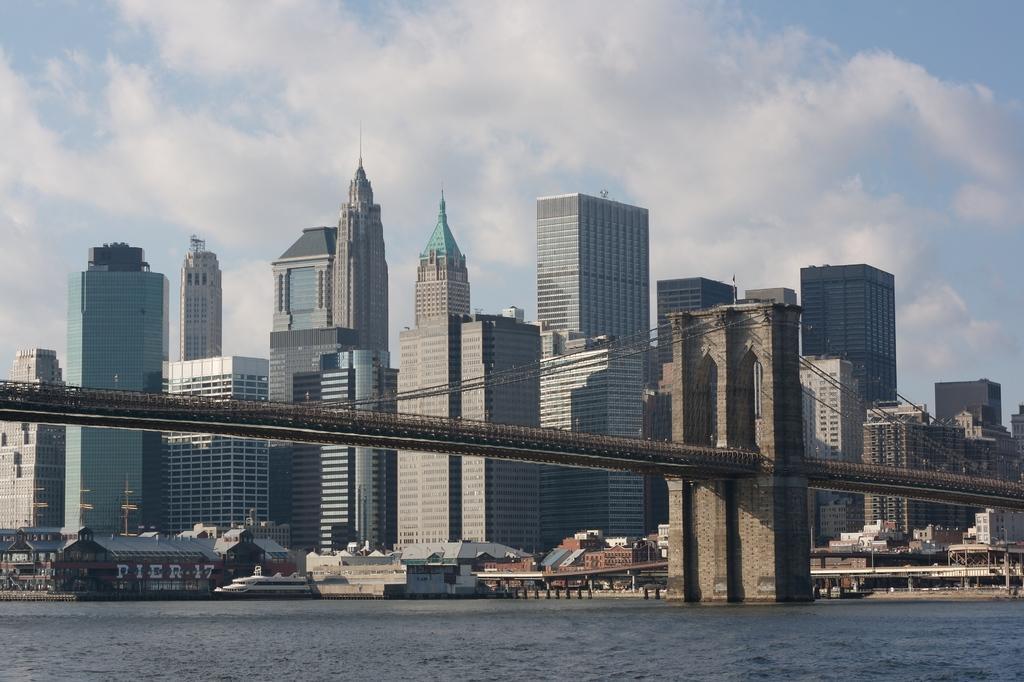In one or two sentences, can you explain what this image depicts? In this image in the foreground there is water body. This is a bridge. In the background there are buildings. The sky is cloudy. 